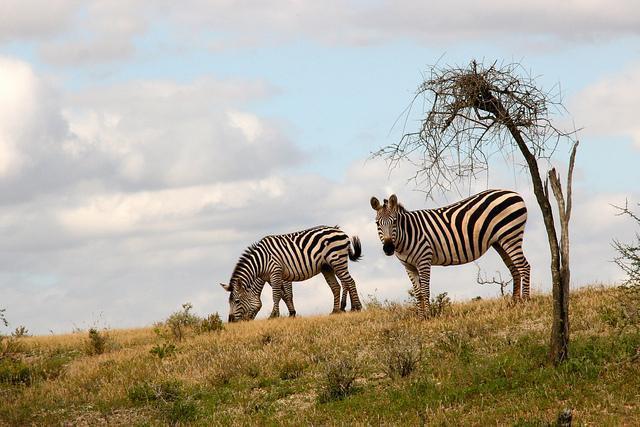How many trees are there?
Give a very brief answer. 1. How many animals are there?
Give a very brief answer. 2. How many zebras are in the picture?
Give a very brief answer. 2. 